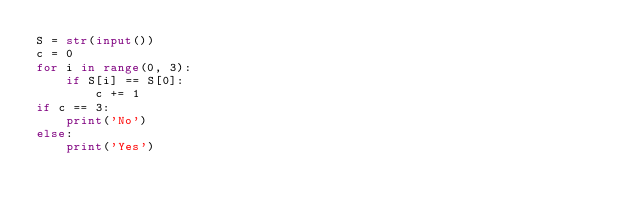Convert code to text. <code><loc_0><loc_0><loc_500><loc_500><_Python_>S = str(input())
c = 0
for i in range(0, 3):
    if S[i] == S[0]:
        c += 1
if c == 3:
    print('No')
else:
    print('Yes')</code> 